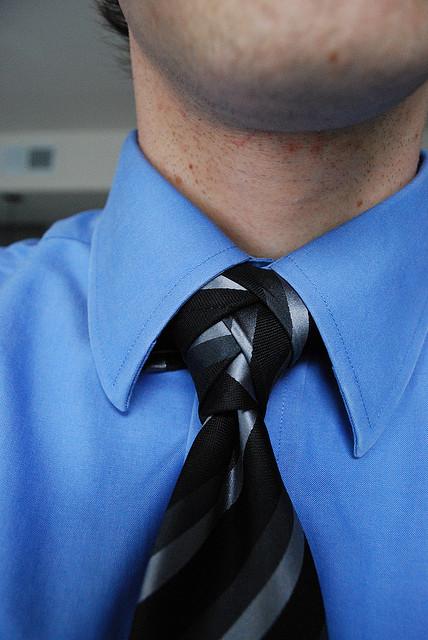What is the gender of this individual?
Give a very brief answer. Male. What type of tie knot has been used?
Be succinct. Windsor. What is the color of the shirt?
Short answer required. Blue. 